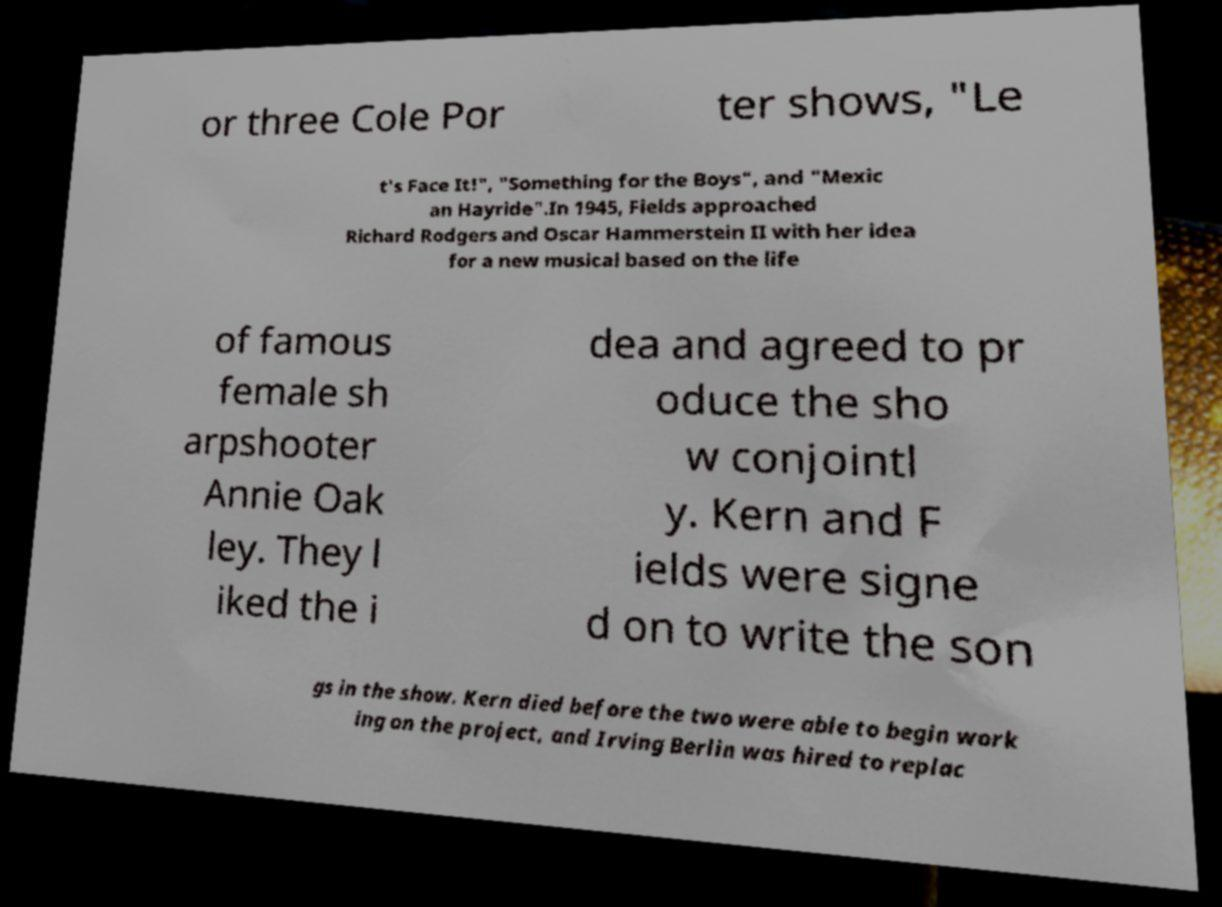Can you accurately transcribe the text from the provided image for me? or three Cole Por ter shows, "Le t's Face It!", "Something for the Boys", and "Mexic an Hayride".In 1945, Fields approached Richard Rodgers and Oscar Hammerstein II with her idea for a new musical based on the life of famous female sh arpshooter Annie Oak ley. They l iked the i dea and agreed to pr oduce the sho w conjointl y. Kern and F ields were signe d on to write the son gs in the show. Kern died before the two were able to begin work ing on the project, and Irving Berlin was hired to replac 